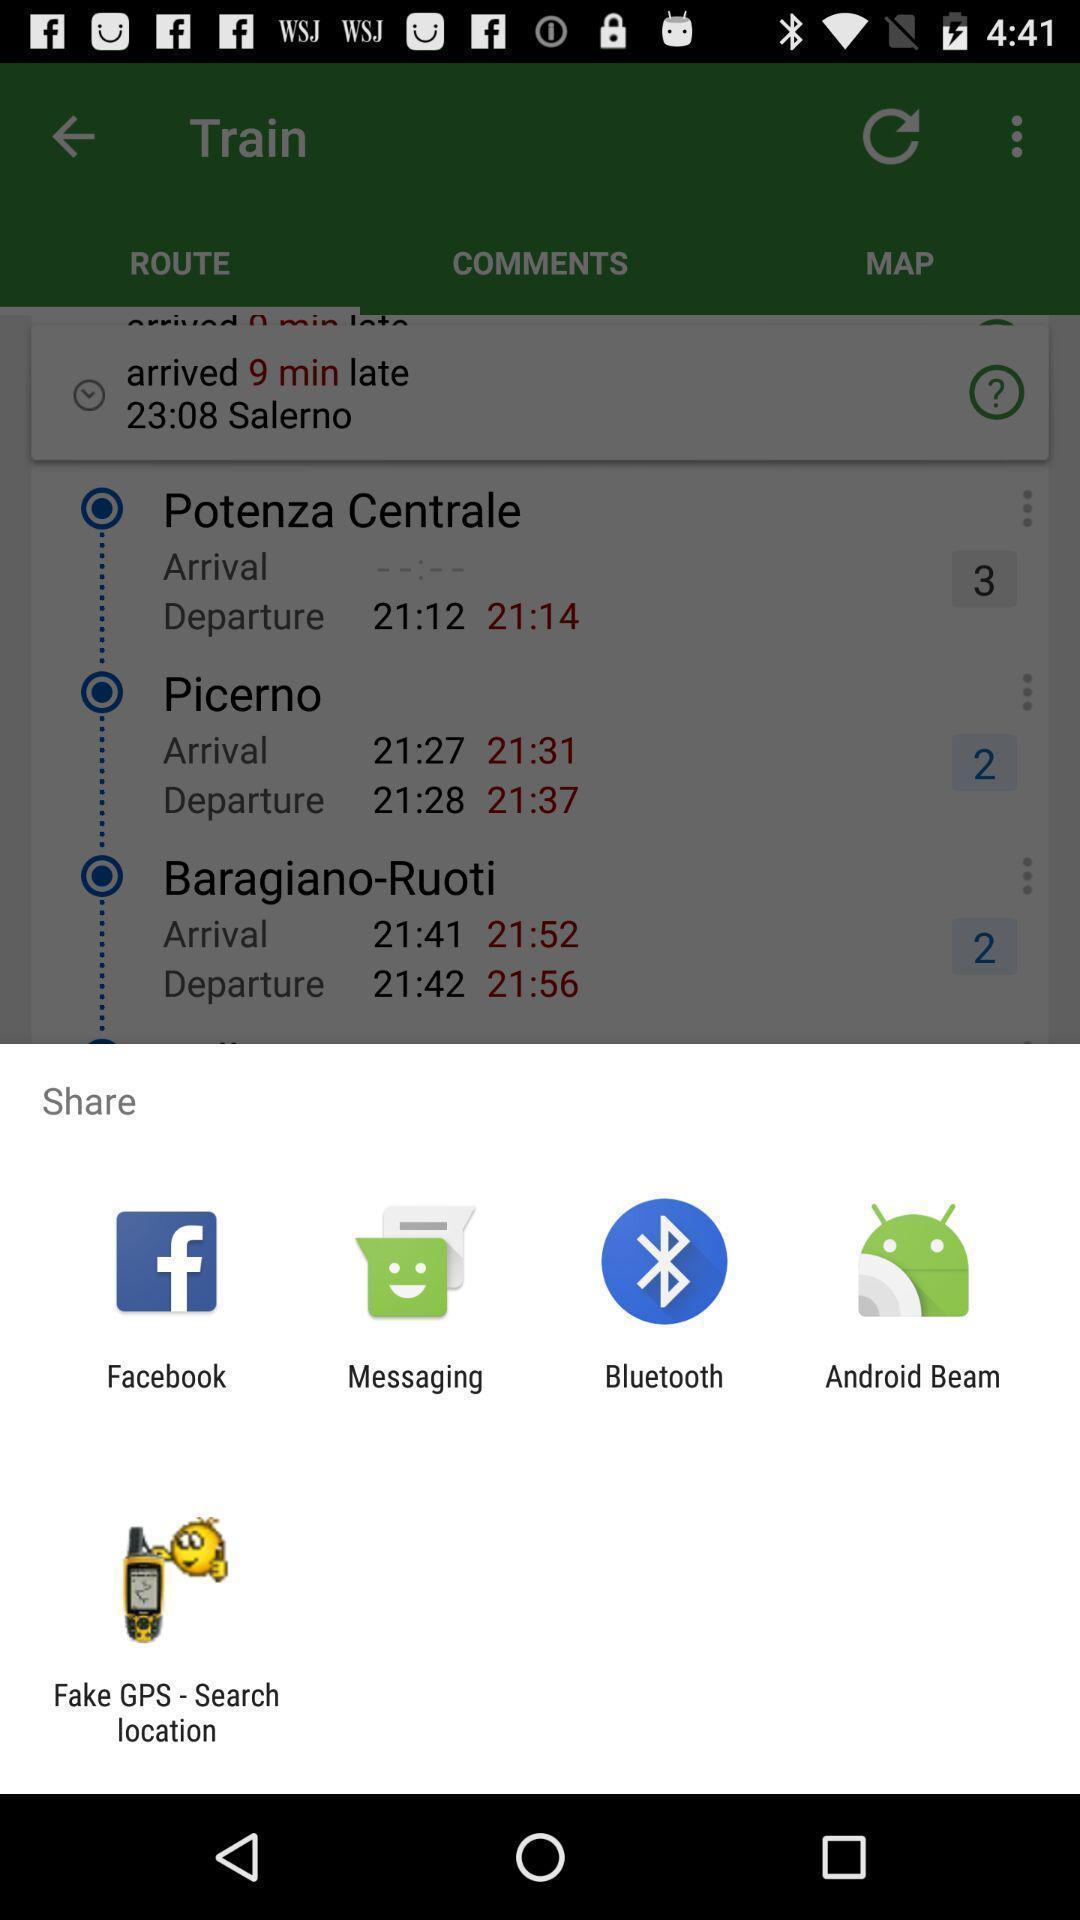Provide a detailed account of this screenshot. Popup to share for the transport tracking app. 